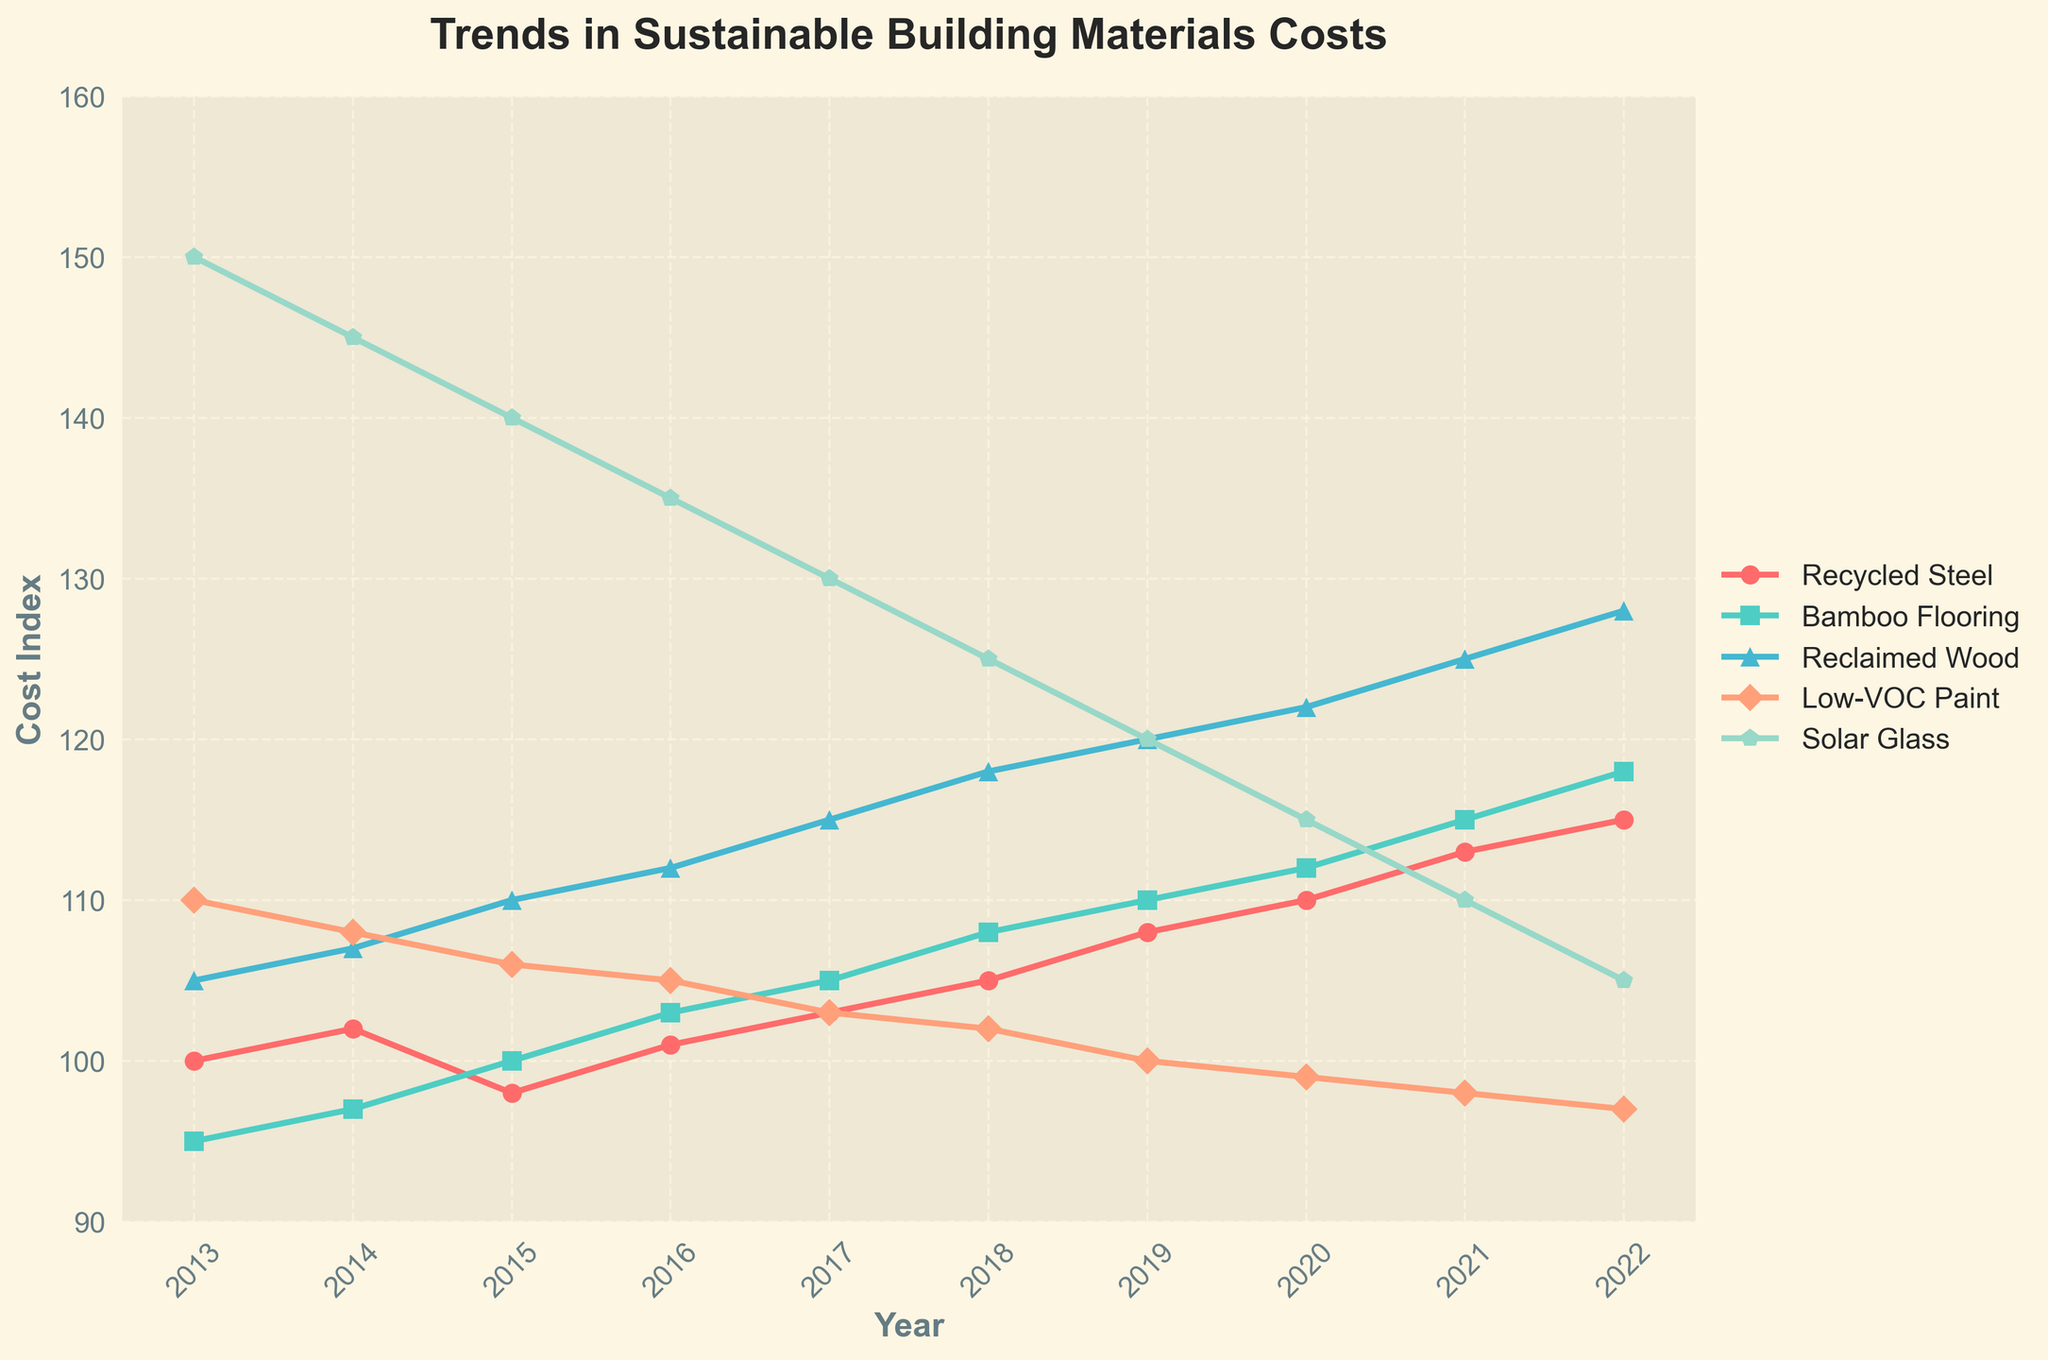What is the cost index difference between Bamboo Flooring and Recycled Steel in 2018? In 2018, the cost index for Bamboo Flooring is 108 and for Recycled Steel is 105. The difference is 108 - 105.
Answer: 3 Which material had the highest cost index in 2013? In 2013, the cost indices are: Recycled Steel - 100, Bamboo Flooring - 95, Reclaimed Wood - 105, Low-VOC Paint - 110, and Solar Glass - 150. The highest is Solar Glass with 150.
Answer: Solar Glass How did the cost index for Low-VOC Paint change from 2015 to 2022? In 2015, the cost index for Low-VOC Paint is 106 and in 2022, it is 97. The change is 97 - 106.
Answer: -9 What is the average cost index of Reclaimed Wood over the decade? Sum the values of Reclaimed Wood from 2013 to 2022: 105 + 107 + 110 + 112 + 115 + 118 + 120 + 122 + 125 + 128 = 1162. There are 10 years, so the average is 1162 / 10.
Answer: 116.2 Which material showed the most consistent decline in cost index from 2013 to 2022? By observing the trends: Recycled Steel fluctuates, Bamboo Flooring generally increases, Reclaimed Wood increases, Low-VOC Paint consistently declines, and Solar Glass declines. Low-VOC Paint shows the most consistent decline.
Answer: Low-VOC Paint Between which two years did Solar Glass experience the greatest drop in cost index? Observing the values for Solar Glass, the largest drop is between 2014 (145) and 2015 (140), which is a 5-point drop.
Answer: 2014 and 2015 What is the overall trend of Recycled Steel's cost index over the decade? Recycled Steel's cost index started at 100 in 2013 and ended at 115 in 2022, generally showing an upward trend over the years.
Answer: Upward trend Compare the cost index trends of Bamboo Flooring and Reclaimed Wood. Which material's cost index increased more over the decade? Bamboo Flooring increased from 95 to 118 (an increase of 23), while Reclaimed Wood went from 105 to 128 (an increase of 23). They both increased by the same amount.
Answer: Both increased equally 